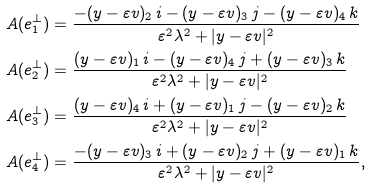<formula> <loc_0><loc_0><loc_500><loc_500>A ( e _ { 1 } ^ { \perp } ) & = \frac { - ( y - \varepsilon v ) _ { 2 } \, i - ( y - \varepsilon v ) _ { 3 } \, j - ( y - \varepsilon v ) _ { 4 } \, k } { \varepsilon ^ { 2 } \lambda ^ { 2 } + | y - \varepsilon v | ^ { 2 } } \\ A ( e _ { 2 } ^ { \perp } ) & = \frac { ( y - \varepsilon v ) _ { 1 } \, i - ( y - \varepsilon v ) _ { 4 } \, j + ( y - \varepsilon v ) _ { 3 } \, k } { \varepsilon ^ { 2 } \lambda ^ { 2 } + | y - \varepsilon v | ^ { 2 } } \\ A ( e _ { 3 } ^ { \perp } ) & = \frac { ( y - \varepsilon v ) _ { 4 } \, i + ( y - \varepsilon v ) _ { 1 } \, j - ( y - \varepsilon v ) _ { 2 } \, k } { \varepsilon ^ { 2 } \lambda ^ { 2 } + | y - \varepsilon v | ^ { 2 } } \\ A ( e _ { 4 } ^ { \perp } ) & = \frac { - ( y - \varepsilon v ) _ { 3 } \, i + ( y - \varepsilon v ) _ { 2 } \, j + ( y - \varepsilon v ) _ { 1 } \, k } { \varepsilon ^ { 2 } \lambda ^ { 2 } + | y - \varepsilon v | ^ { 2 } } ,</formula> 